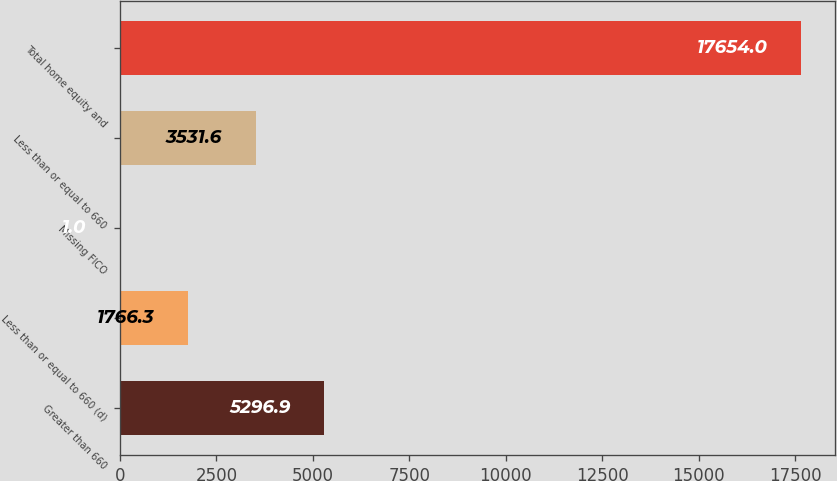Convert chart. <chart><loc_0><loc_0><loc_500><loc_500><bar_chart><fcel>Greater than 660<fcel>Less than or equal to 660 (d)<fcel>Missing FICO<fcel>Less than or equal to 660<fcel>Total home equity and<nl><fcel>5296.9<fcel>1766.3<fcel>1<fcel>3531.6<fcel>17654<nl></chart> 